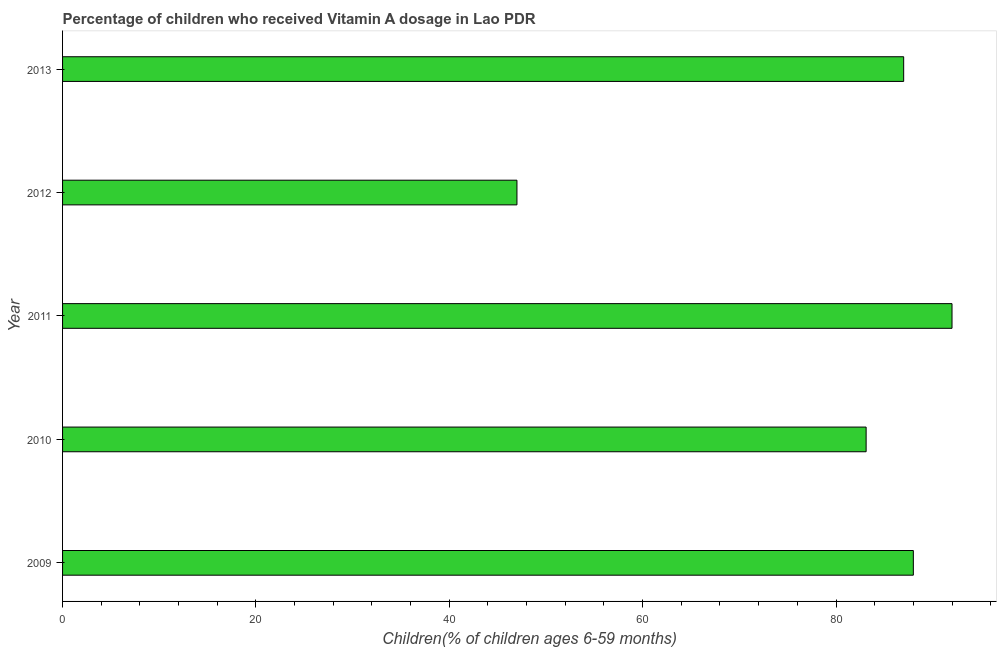Does the graph contain any zero values?
Your answer should be compact. No. Does the graph contain grids?
Your response must be concise. No. What is the title of the graph?
Provide a short and direct response. Percentage of children who received Vitamin A dosage in Lao PDR. What is the label or title of the X-axis?
Offer a very short reply. Children(% of children ages 6-59 months). What is the label or title of the Y-axis?
Your answer should be very brief. Year. What is the vitamin a supplementation coverage rate in 2010?
Your answer should be very brief. 83.12. Across all years, what is the maximum vitamin a supplementation coverage rate?
Make the answer very short. 92. Across all years, what is the minimum vitamin a supplementation coverage rate?
Offer a very short reply. 47. In which year was the vitamin a supplementation coverage rate maximum?
Offer a very short reply. 2011. In which year was the vitamin a supplementation coverage rate minimum?
Your response must be concise. 2012. What is the sum of the vitamin a supplementation coverage rate?
Provide a short and direct response. 397.12. What is the average vitamin a supplementation coverage rate per year?
Provide a succinct answer. 79.42. In how many years, is the vitamin a supplementation coverage rate greater than 60 %?
Provide a succinct answer. 4. Do a majority of the years between 2009 and 2012 (inclusive) have vitamin a supplementation coverage rate greater than 44 %?
Ensure brevity in your answer.  Yes. What is the ratio of the vitamin a supplementation coverage rate in 2009 to that in 2010?
Your answer should be compact. 1.06. Is the vitamin a supplementation coverage rate in 2010 less than that in 2011?
Provide a short and direct response. Yes. Is the difference between the vitamin a supplementation coverage rate in 2010 and 2012 greater than the difference between any two years?
Make the answer very short. No. What is the difference between the highest and the second highest vitamin a supplementation coverage rate?
Provide a short and direct response. 4. Is the sum of the vitamin a supplementation coverage rate in 2010 and 2011 greater than the maximum vitamin a supplementation coverage rate across all years?
Keep it short and to the point. Yes. In how many years, is the vitamin a supplementation coverage rate greater than the average vitamin a supplementation coverage rate taken over all years?
Provide a short and direct response. 4. Are all the bars in the graph horizontal?
Your answer should be very brief. Yes. How many years are there in the graph?
Your response must be concise. 5. Are the values on the major ticks of X-axis written in scientific E-notation?
Ensure brevity in your answer.  No. What is the Children(% of children ages 6-59 months) in 2009?
Provide a short and direct response. 88. What is the Children(% of children ages 6-59 months) in 2010?
Provide a short and direct response. 83.12. What is the Children(% of children ages 6-59 months) in 2011?
Provide a succinct answer. 92. What is the Children(% of children ages 6-59 months) in 2012?
Your answer should be very brief. 47. What is the Children(% of children ages 6-59 months) of 2013?
Keep it short and to the point. 87. What is the difference between the Children(% of children ages 6-59 months) in 2009 and 2010?
Your answer should be compact. 4.88. What is the difference between the Children(% of children ages 6-59 months) in 2009 and 2012?
Make the answer very short. 41. What is the difference between the Children(% of children ages 6-59 months) in 2009 and 2013?
Provide a short and direct response. 1. What is the difference between the Children(% of children ages 6-59 months) in 2010 and 2011?
Your response must be concise. -8.88. What is the difference between the Children(% of children ages 6-59 months) in 2010 and 2012?
Give a very brief answer. 36.12. What is the difference between the Children(% of children ages 6-59 months) in 2010 and 2013?
Your answer should be very brief. -3.88. What is the difference between the Children(% of children ages 6-59 months) in 2011 and 2012?
Keep it short and to the point. 45. What is the difference between the Children(% of children ages 6-59 months) in 2012 and 2013?
Provide a short and direct response. -40. What is the ratio of the Children(% of children ages 6-59 months) in 2009 to that in 2010?
Your answer should be very brief. 1.06. What is the ratio of the Children(% of children ages 6-59 months) in 2009 to that in 2012?
Provide a succinct answer. 1.87. What is the ratio of the Children(% of children ages 6-59 months) in 2010 to that in 2011?
Provide a succinct answer. 0.9. What is the ratio of the Children(% of children ages 6-59 months) in 2010 to that in 2012?
Your response must be concise. 1.77. What is the ratio of the Children(% of children ages 6-59 months) in 2010 to that in 2013?
Make the answer very short. 0.95. What is the ratio of the Children(% of children ages 6-59 months) in 2011 to that in 2012?
Your answer should be compact. 1.96. What is the ratio of the Children(% of children ages 6-59 months) in 2011 to that in 2013?
Ensure brevity in your answer.  1.06. What is the ratio of the Children(% of children ages 6-59 months) in 2012 to that in 2013?
Your answer should be very brief. 0.54. 